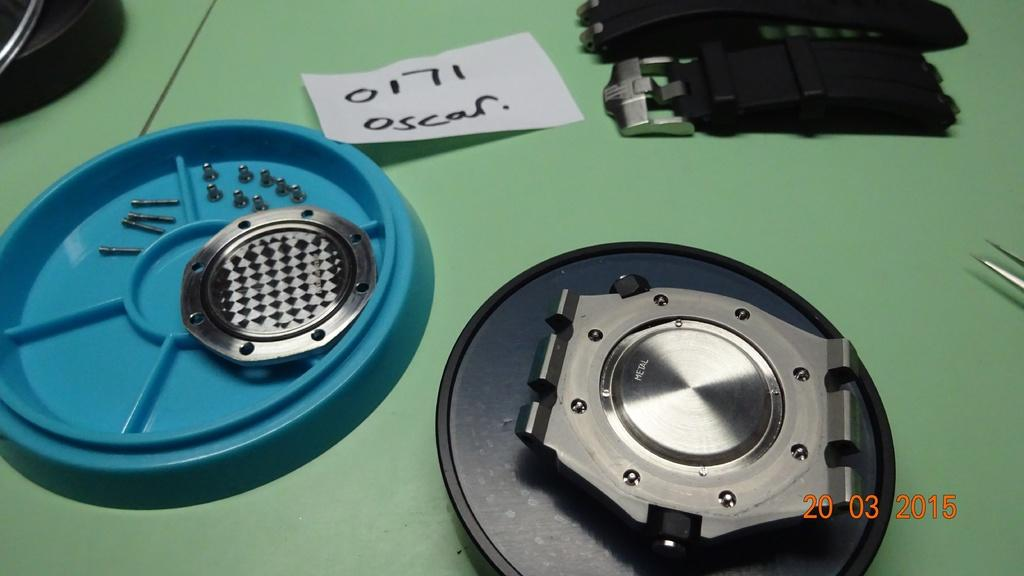What is the color of the table in the image? The table has a green color. What can be found on the table in the image? There are objects on the table in the image. Is there a gun visible on the table in the image? No, there is no gun present in the image. 